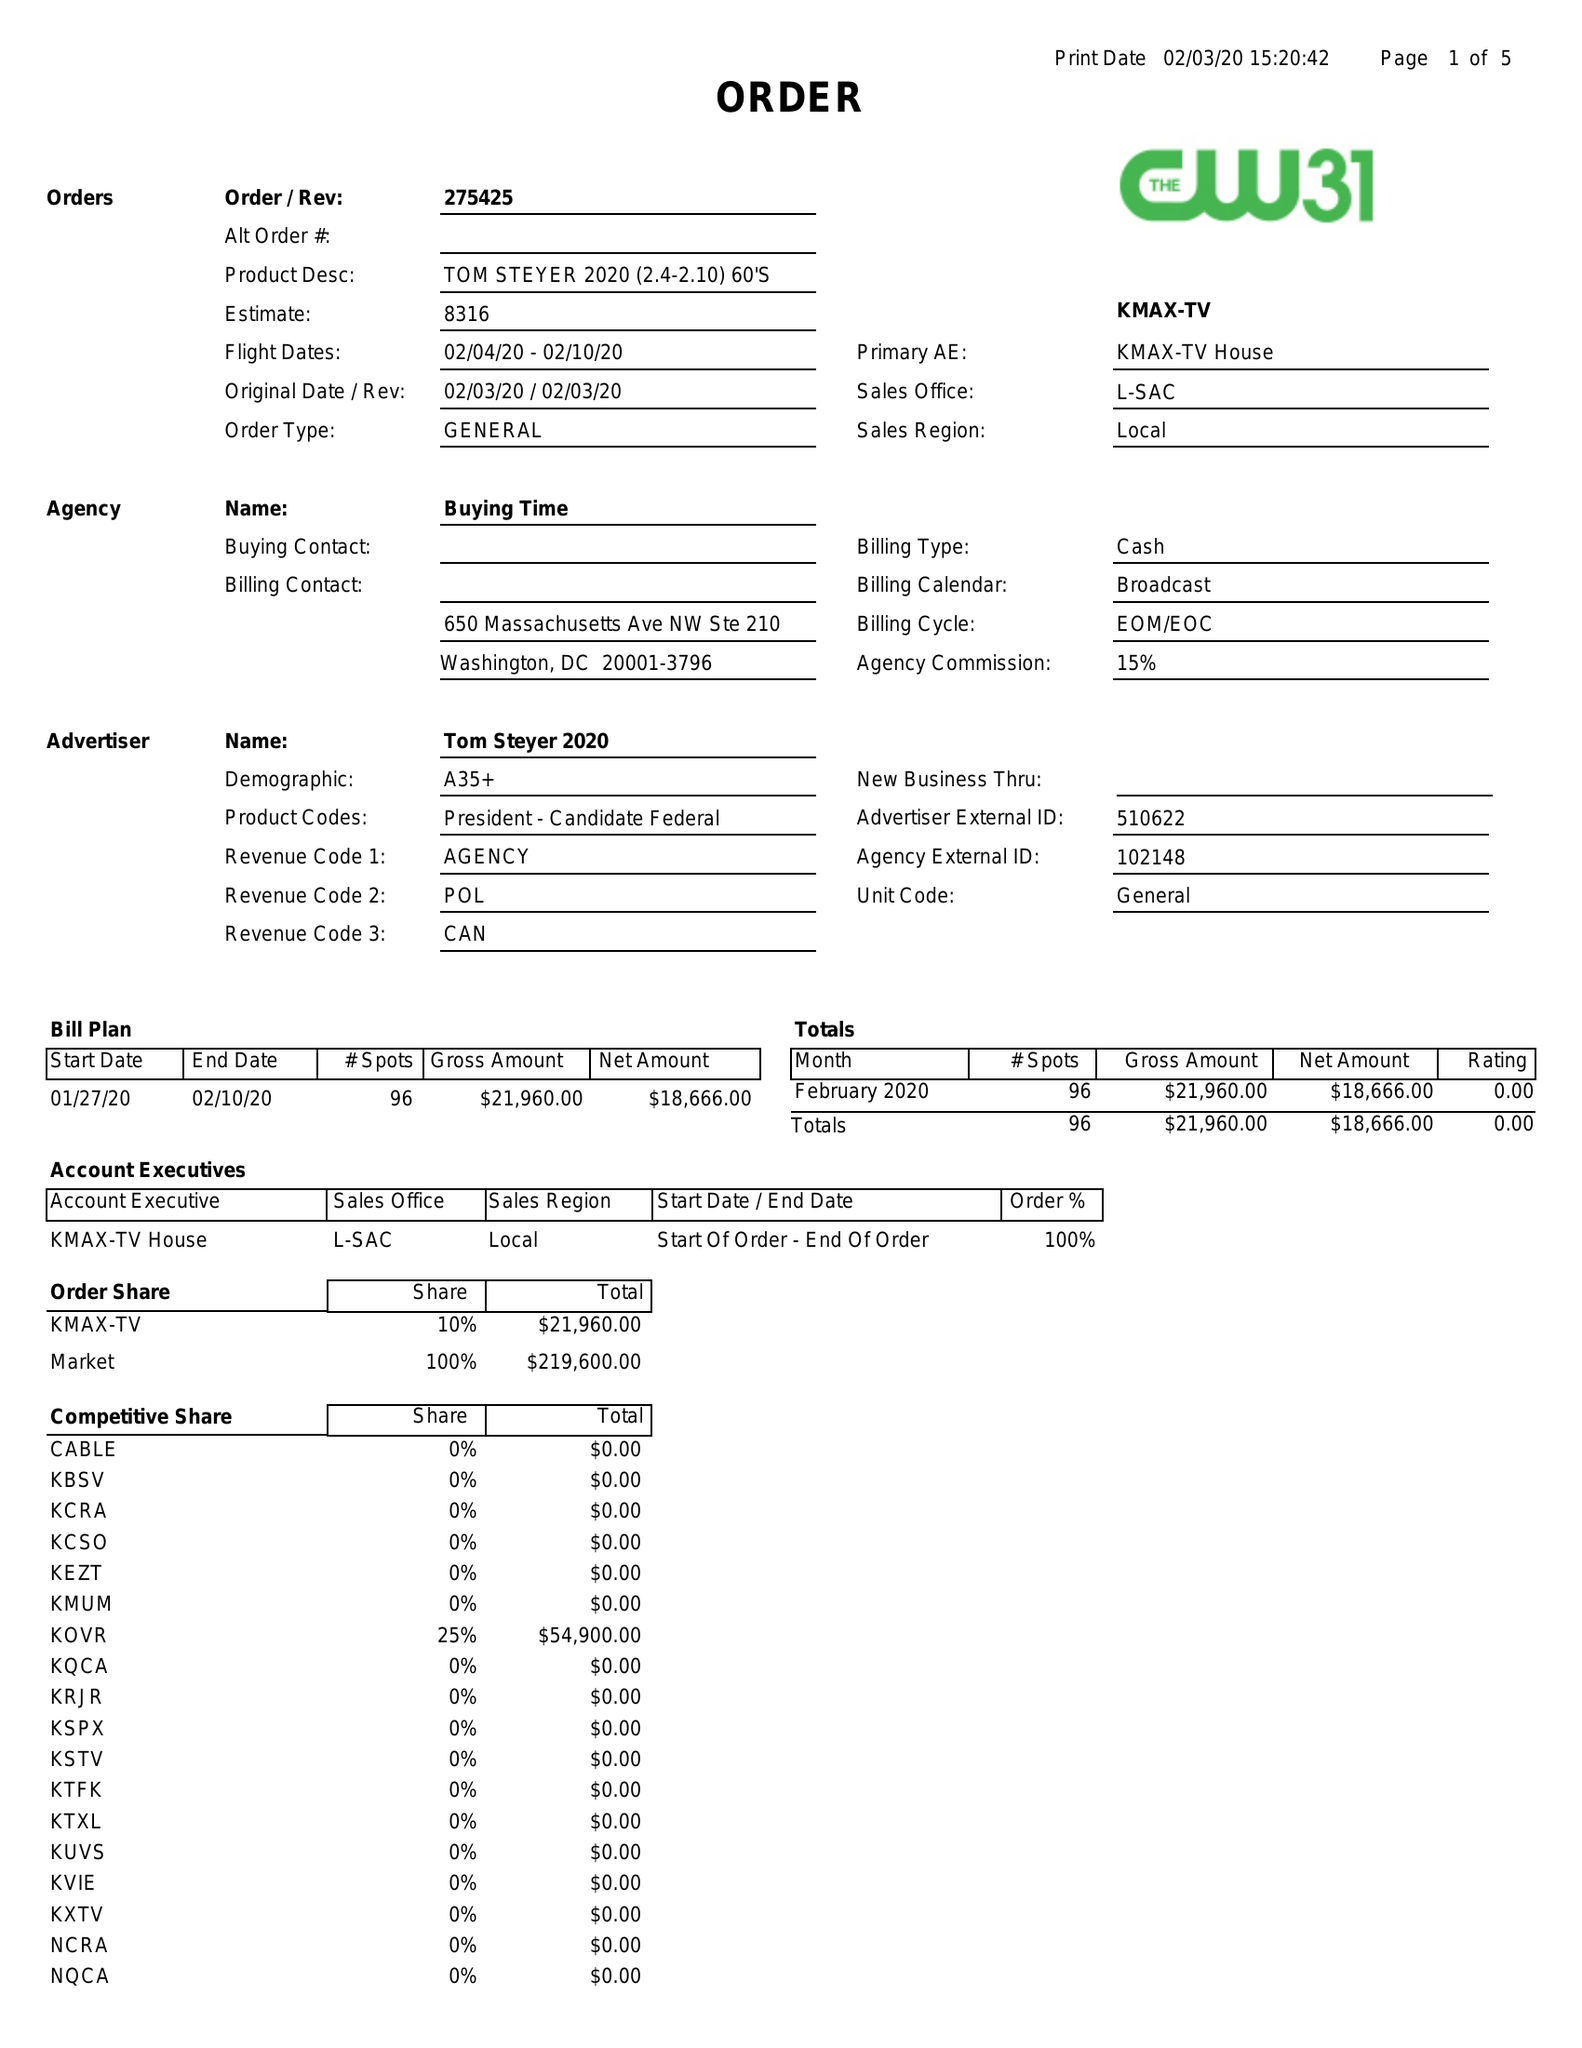What is the value for the contract_num?
Answer the question using a single word or phrase. 275425 